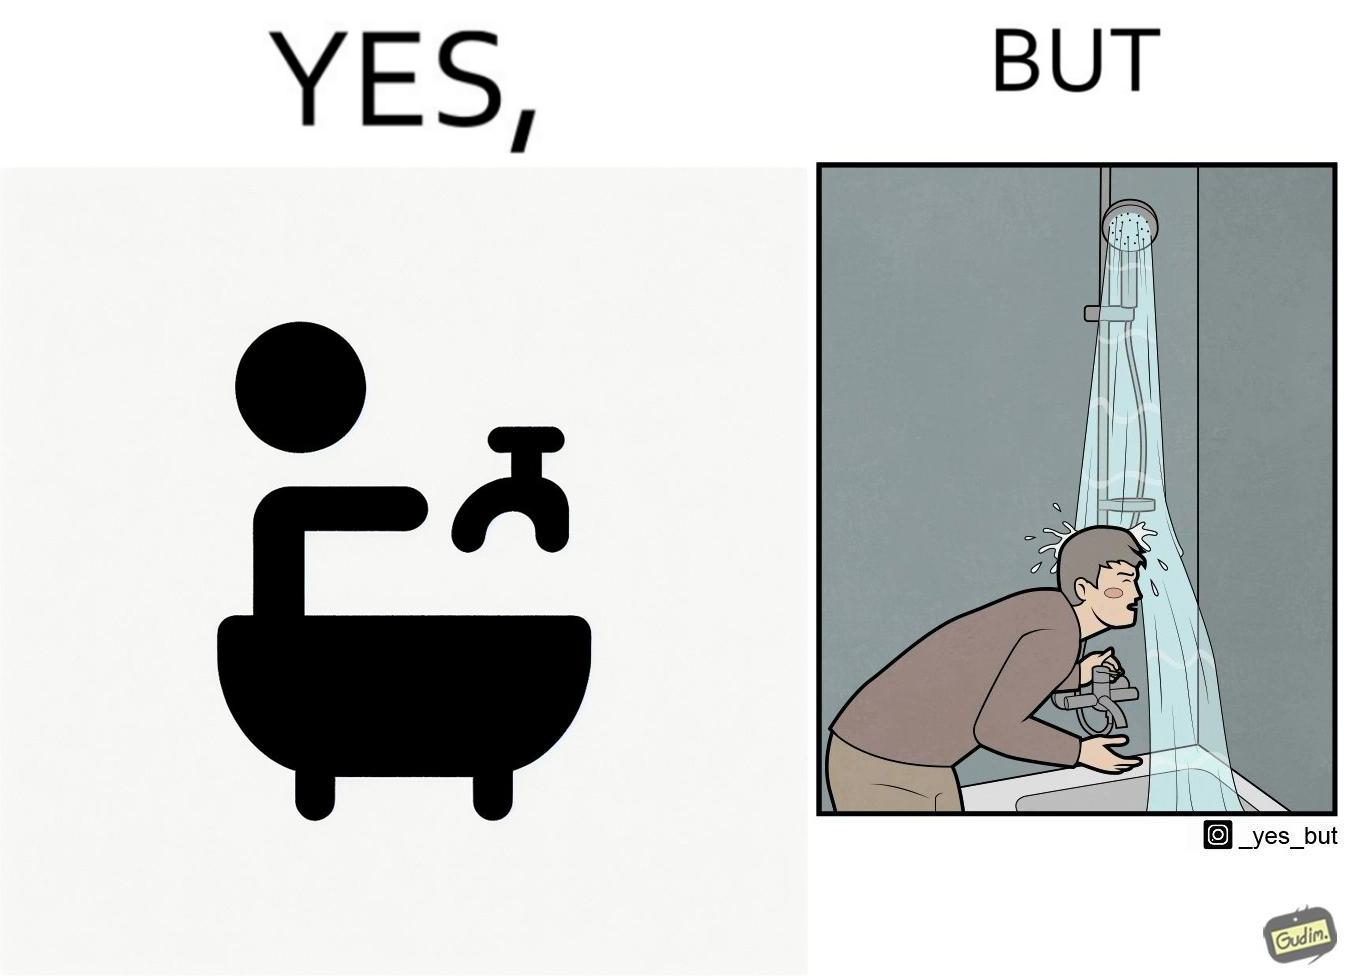Provide a description of this image. The image is funny, as the person is trying to operate the tap, but water comes out of the handheld shower resting on a holder instead of the tap, making the person drenched in water. 